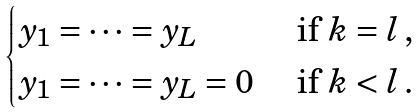Convert formula to latex. <formula><loc_0><loc_0><loc_500><loc_500>\begin{cases} y _ { 1 } = \dots = y _ { L } & \text { if } k = l \, , \\ y _ { 1 } = \dots = y _ { L } = 0 & \text { if } k < l \, . \end{cases}</formula> 